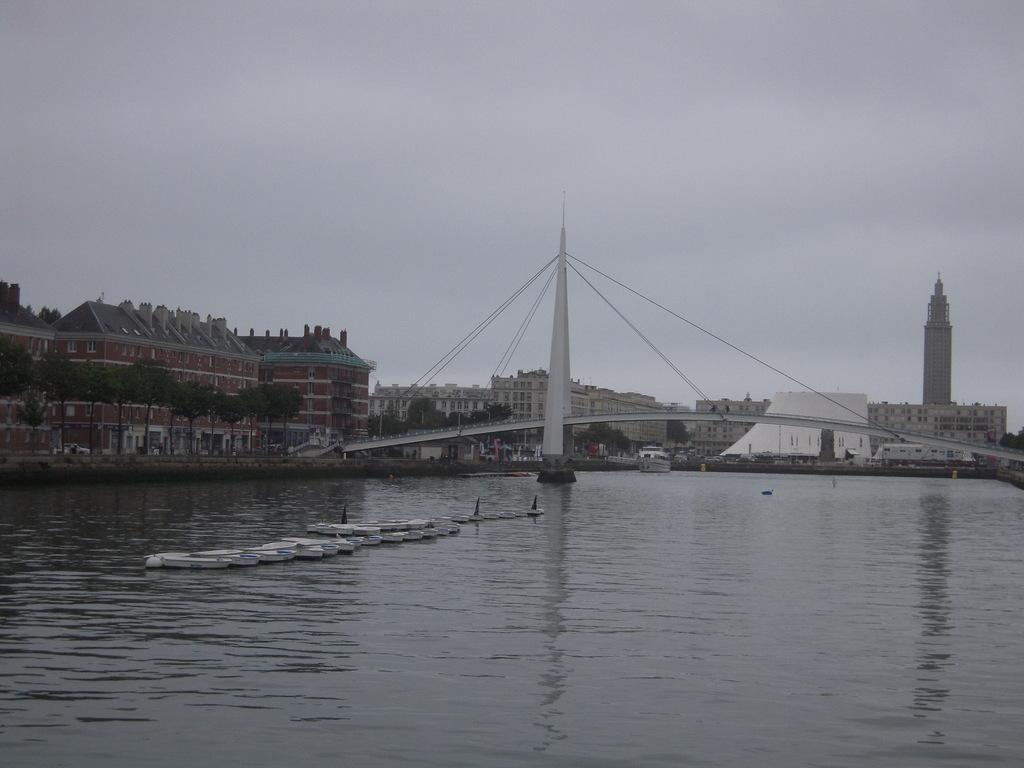What type of structures can be seen in the image? There are buildings, a bridge, and a tower in the image. What natural elements are present in the image? There are trees and water in the image. What is visible in the sky in the image? The sky is visible in the image. What type of transportation can be seen in the water? There are boats in the water in the image. What type of kitty is sitting on the roof of the tower in the image? There is no kitty present in the image, and there is no roof on the tower. What decisions is the committee making in the image? There is no committee present in the image, and no decisions are being made. 